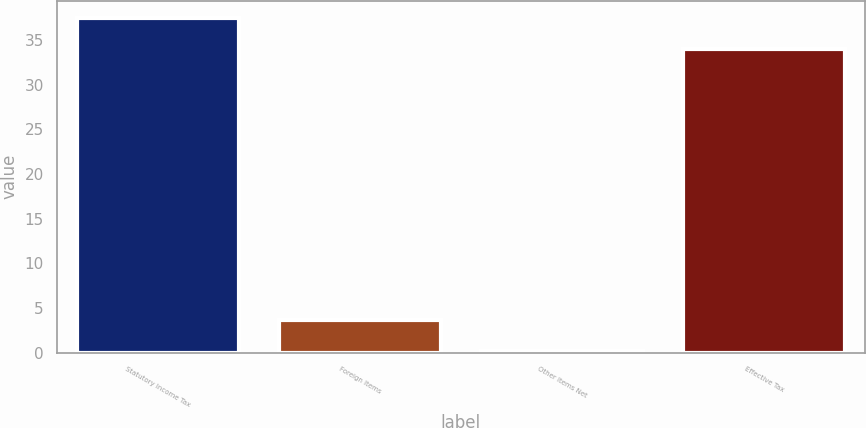Convert chart. <chart><loc_0><loc_0><loc_500><loc_500><bar_chart><fcel>Statutory Income Tax<fcel>Foreign Items<fcel>Other Items Net<fcel>Effective Tax<nl><fcel>37.48<fcel>3.68<fcel>0.2<fcel>34<nl></chart> 